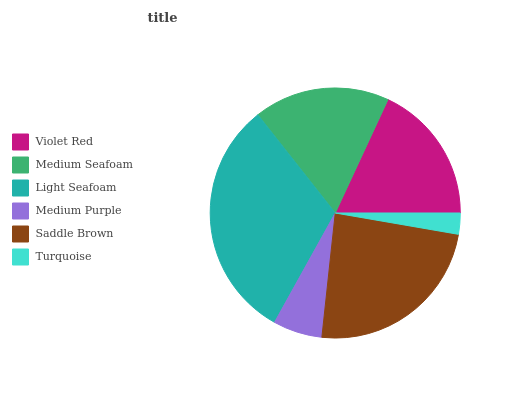Is Turquoise the minimum?
Answer yes or no. Yes. Is Light Seafoam the maximum?
Answer yes or no. Yes. Is Medium Seafoam the minimum?
Answer yes or no. No. Is Medium Seafoam the maximum?
Answer yes or no. No. Is Violet Red greater than Medium Seafoam?
Answer yes or no. Yes. Is Medium Seafoam less than Violet Red?
Answer yes or no. Yes. Is Medium Seafoam greater than Violet Red?
Answer yes or no. No. Is Violet Red less than Medium Seafoam?
Answer yes or no. No. Is Violet Red the high median?
Answer yes or no. Yes. Is Medium Seafoam the low median?
Answer yes or no. Yes. Is Turquoise the high median?
Answer yes or no. No. Is Light Seafoam the low median?
Answer yes or no. No. 